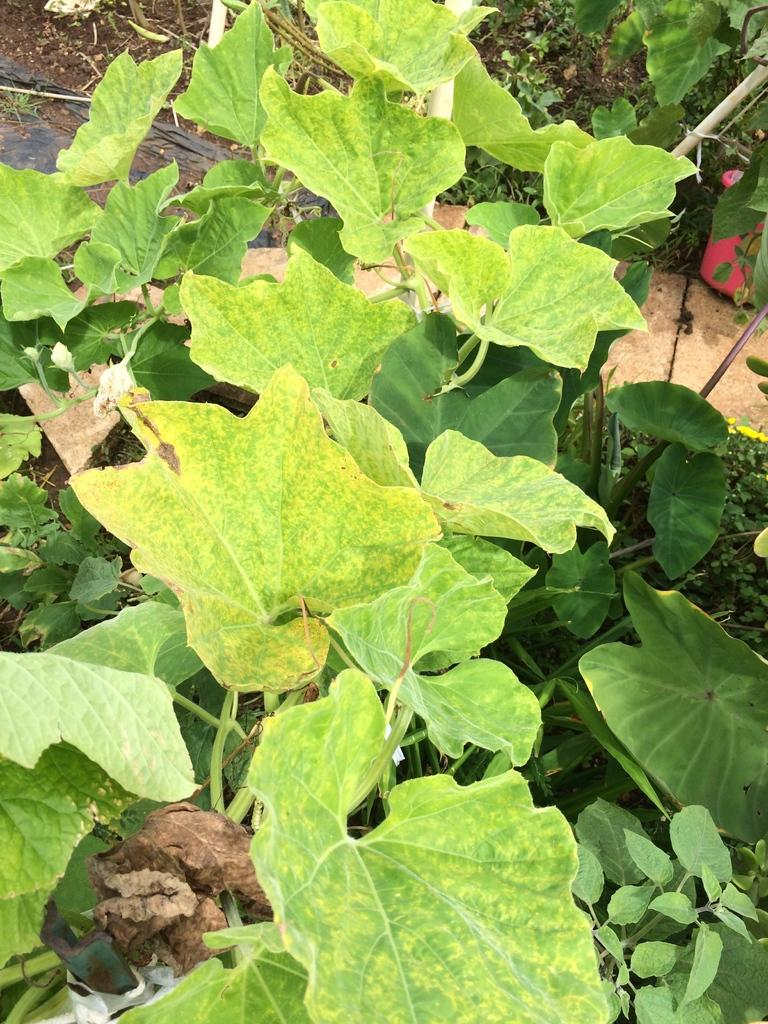What is the main subject of the zoomed in picture? The main subject of the picture is the leaves of a plant. Can you describe the level of detail in the image? The image is a zoomed in picture, which means it provides a close-up view of the leaves. What type of doctor can be seen examining the leaves in the image? There is no doctor present in the image; it only features the leaves of a plant. What historical event is depicted in the image? There is no historical event depicted in the image; it only features the leaves of a plant. 